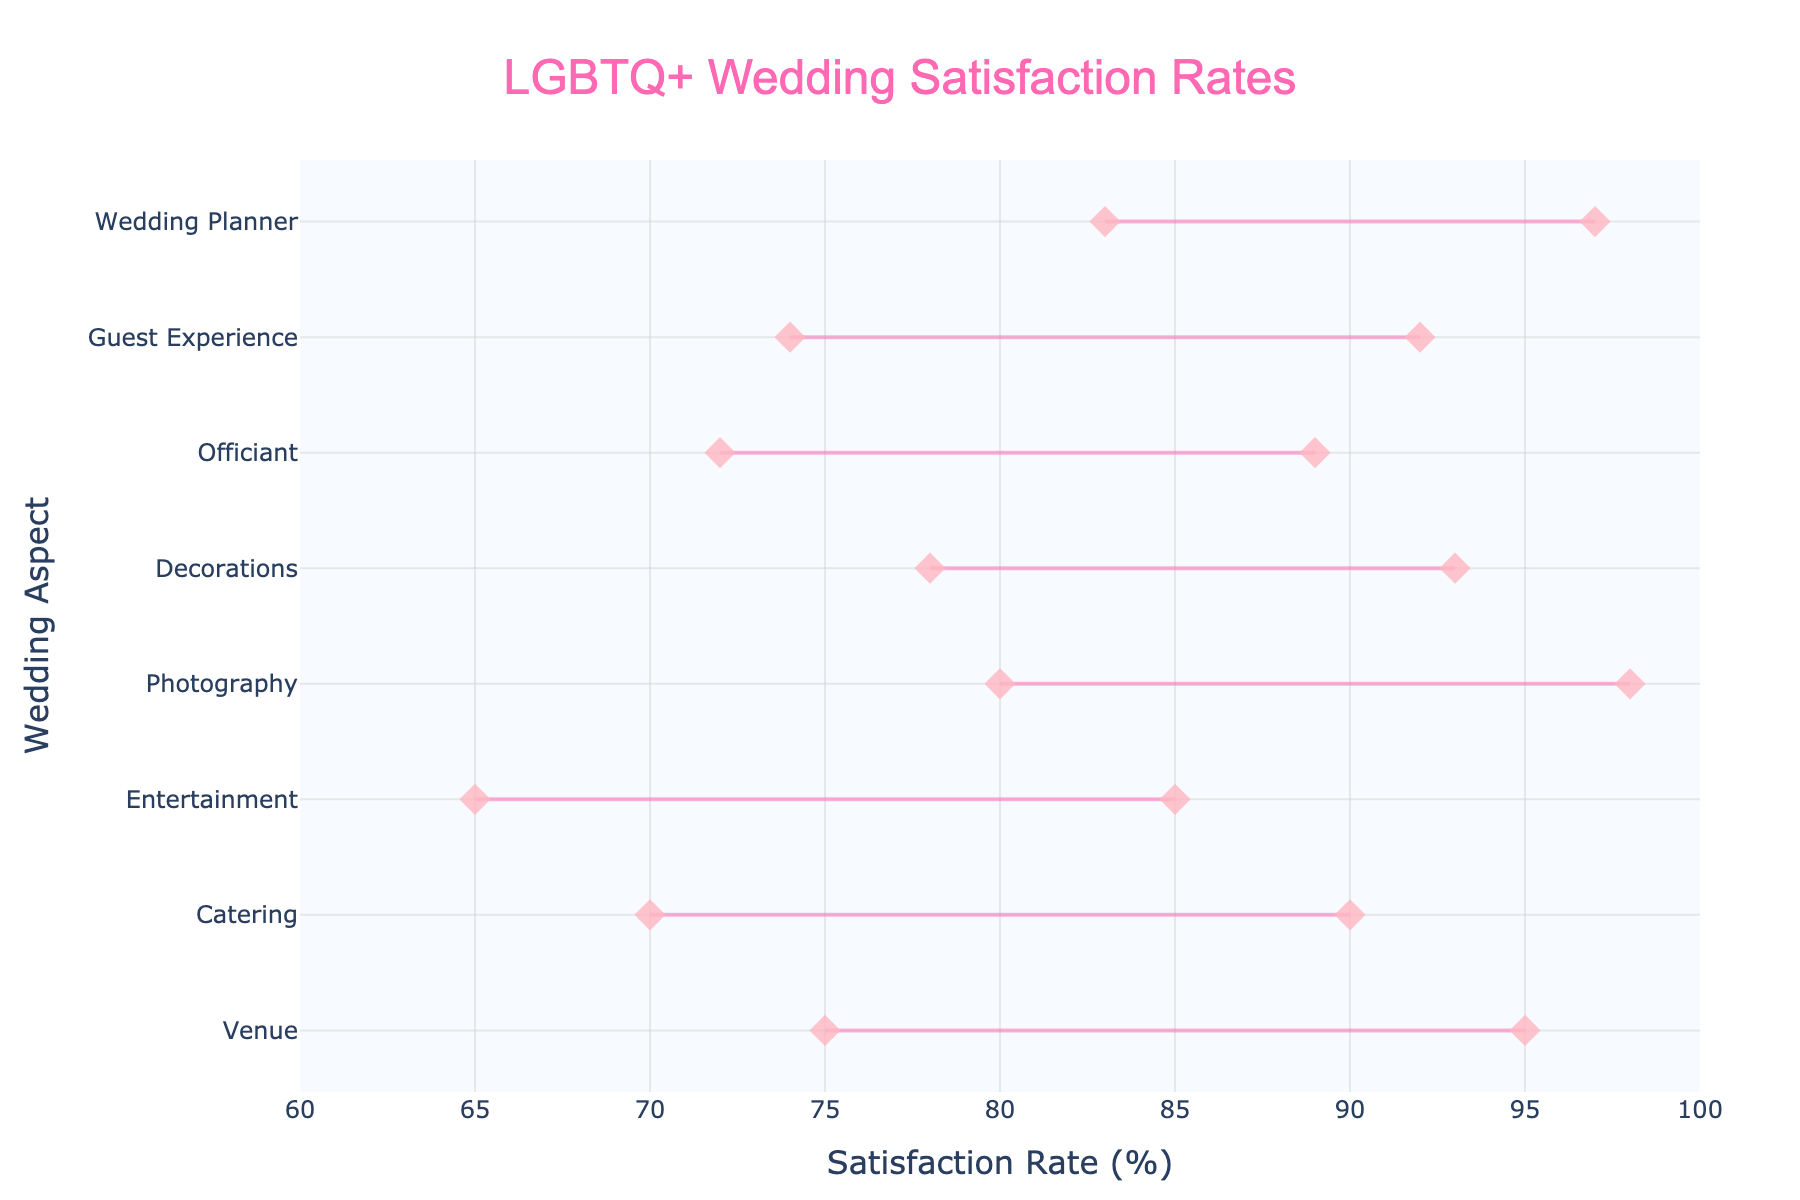What's the title of the chart? The title is usually displayed at the top of the chart. In this case, it reads 'LGBTQ+ Wedding Satisfaction Rates'.
Answer: 'LGBTQ+ Wedding Satisfaction Rates' What aspect has the highest maximum satisfaction rate? To find out which aspect has the highest maximum satisfaction rate, look for the dot that is furthest to the right on the x-axis. 'Photography' reaches 98%.
Answer: Photography Which aspect has the lowest minimum satisfaction rate? The lowest minimum satisfaction rate can be found by inspecting which aspect has a leftmost point on the x-axis. 'Entertainment' has a minimum satisfaction rate of 65%.
Answer: Entertainment What's the average of the maximum satisfaction rates across all aspects? Sum all max rates (95 + 90 + 85 + 98 + 93 + 89 + 92 + 97) and divide by the total number of aspects (8). The sum is 739, so the average is 739/8 = 92.375.
Answer: 92.375 How does the satisfaction range of 'Venue' compare to 'Catering'? The satisfaction range is calculated by subtracting the minimum rate from the maximum rate. For 'Venue,' it's 95-75=20. For 'Catering,' it's 90-70=20.
Answer: They are equal Which aspect shows the narrowest range of satisfaction rates? The narrowest range can be identified by calculating the difference for each aspect. 'Wedding Planner' has the narrowest range of 97-83=14.
Answer: Wedding Planner Is there any aspect where the minimum satisfaction rate is above 80%? The minimum satisfaction rates are inspected to check if any are above 80%. 'Photography' has a minimum satisfaction rate of 80%.
Answer: Yes, Photography What is the total range of the satisfaction for 'Guest Experience'? Calculate the difference between the max and min satisfaction rates for 'Guest Experience.' It is 92-74=18.
Answer: 18 Which aspect is reviewed with the second highest maximum satisfaction rate? The second highest maximum satisfaction rate is obtained by finding the next highest point after the top one. 'Wedding Planner' has 97%.
Answer: Wedding Planner Is 'Decorations' overall satisfaction spread more than 'Officiant'? Calculate the range for both. 'Decorations' range is 15 (93-78), and 'Officiant' is 17 (89-72). 'Officiant' has a wider spread.
Answer: No 